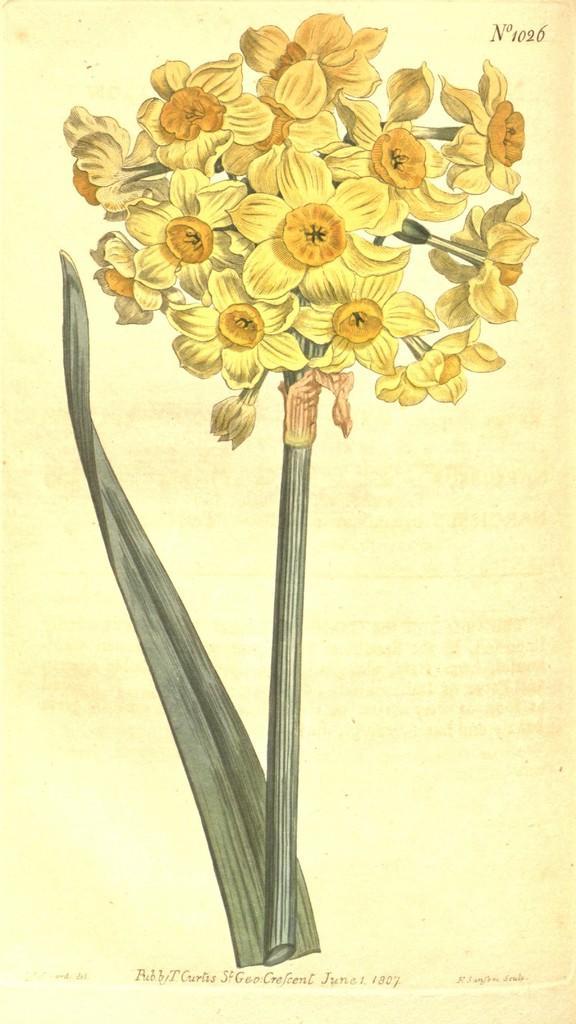In one or two sentences, can you explain what this image depicts? In the foreground of this animated picture, there are bunch of flowers and a leaf to it with the creamy background. 